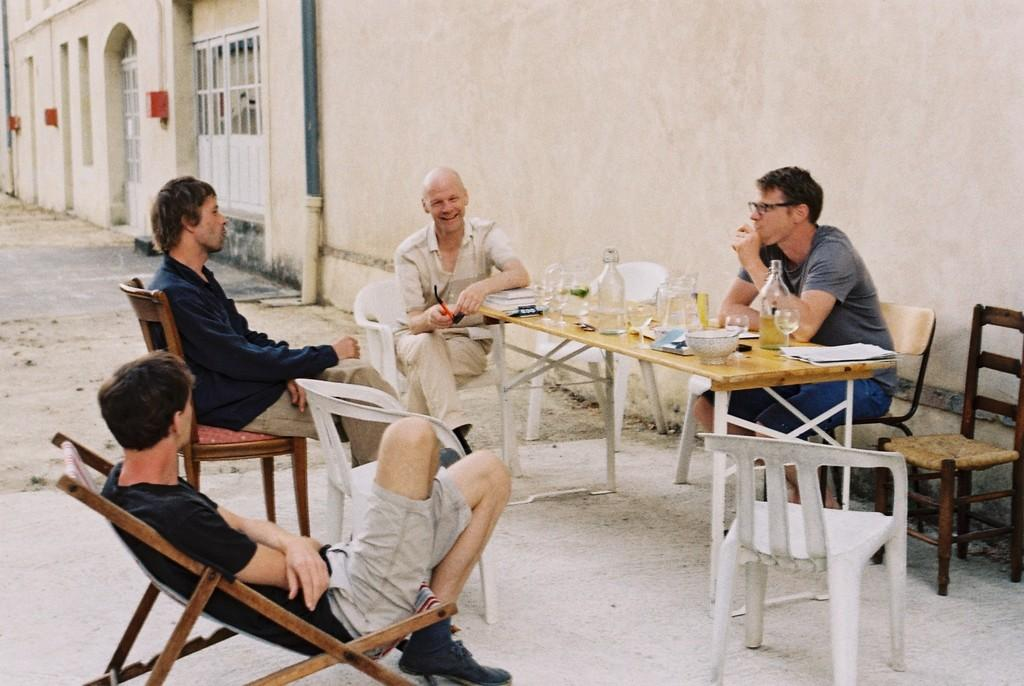How many people are present in the image? There are four people in the image. What are the people doing in the image? The people are sitting around a table. What can be seen on the table? There are things on the table. Are there any empty chairs in the image? Yes, there are two additional chairs beside the table. How many eggs are on the table in the image? There is no information about eggs being present on the table in the image. 